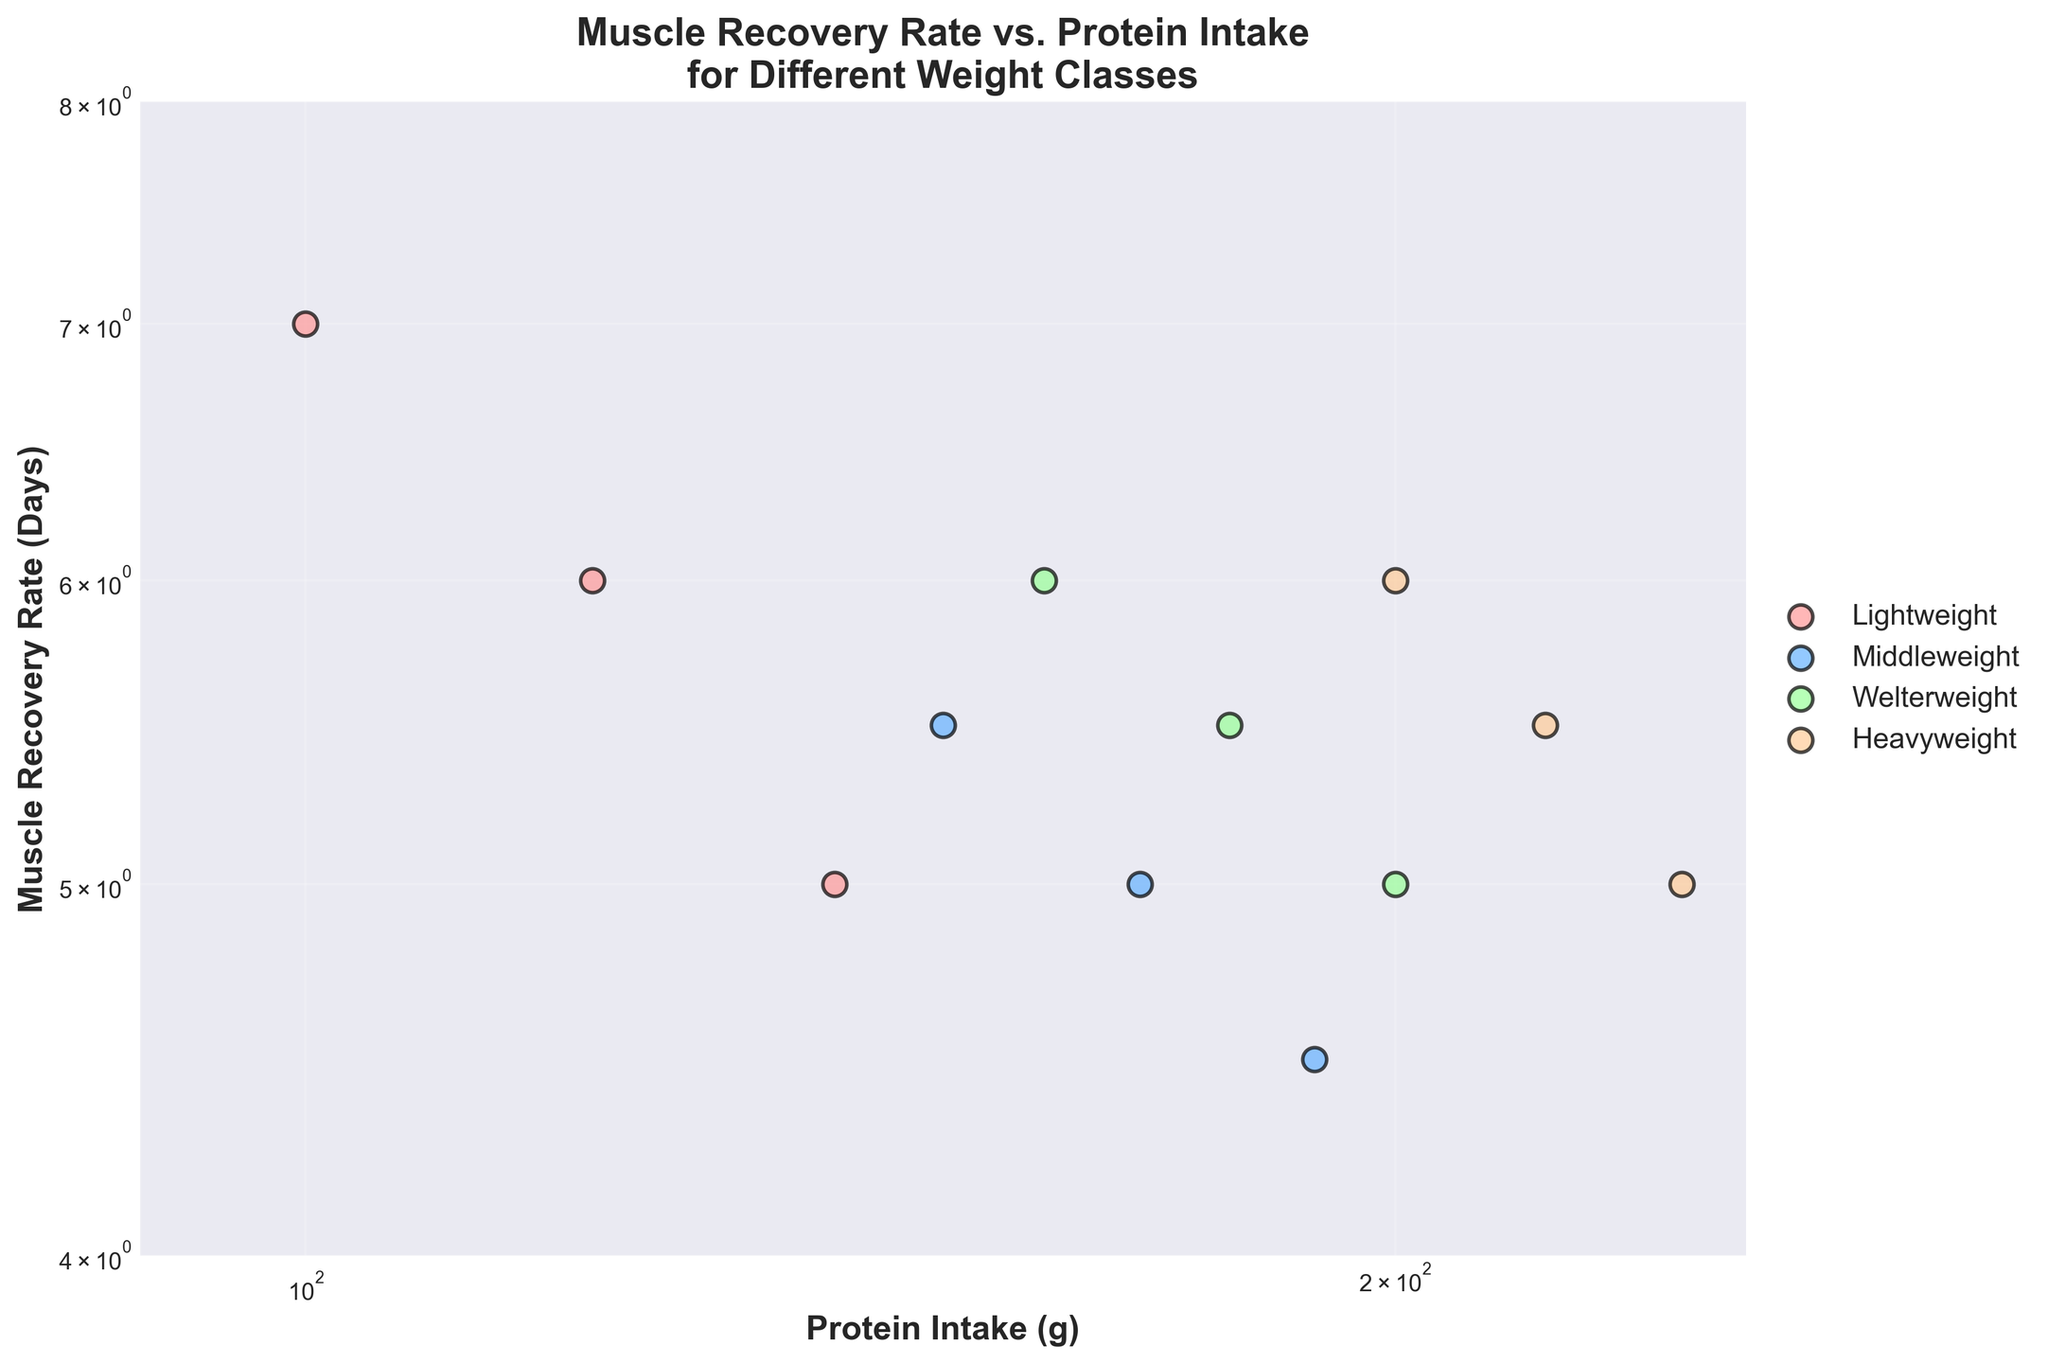What is the title of the plot? The title of the plot is written at the top and it reads: "Muscle Recovery Rate vs. Protein Intake for Different Weight Classes".
Answer: Muscle Recovery Rate vs. Protein Intake for Different Weight Classes What is the range of the x-axis? The range of the x-axis can be found at the bottom of the plot, from the lowest to the highest labeled value. It spans from 90 to 250 grams of protein intake.
Answer: 90 to 250 What is the range of the y-axis? The range of the y-axis can be found on the left side of the plot, from the lowest to the highest labeled value. It spans from 4 to 8 days of muscle recovery rate.
Answer: 4 to 8 How many different weight classes are represented in the plot? The number of different weight classes is indicated by the legend on the side of the plot. Each class has its unique label and color. There are four weight classes: Lightweight, Middleweight, Welterweight, and Heavyweight.
Answer: 4 Which weight class has the highest amount of protein intake shown? To determine the weight class with the highest protein intake, look at the rightmost data point in the plot. The highest value of protein intake is 240 grams, belonging to the Heavyweight class.
Answer: Heavyweight What is the protein intake for the data point with a muscle recovery rate of 5 Days in the Welterweight class? To find this, locate the data point along the y-axis at 5 Days recovery rate and identify the protein intake value on the x-axis within the Welterweight category. The protein intake is 200 grams.
Answer: 200 grams Between Middleweight and Welterweight, which class shows a better muscle recovery rate at a protein intake of approximately 170 grams? To compare, find the data points for both classes near 170 grams protein intake and compare their recovery rates. Middleweight at 170 grams shows a recovery rate of 5 days, while Welterweight at 180 grams (closest to 170) shows a recovery rate of 5.5 days. Thus, Middleweight has a better recovery rate.
Answer: Middleweight Do any data points for the Heavyweight class exhibit a muscle recovery rate of less than 5 days? Find all data points for the Heavyweight class and check their position on the y-axis to see if any fall below 5 days. None of the data points for the Heavyweight class have a muscle recovery rate of less than 5 days.
Answer: No What's the difference in muscle recovery rates between the data points with the highest and lowest protein intakes in the Lightweight class? Identify the highest and lowest protein intakes for Lightweight (100g and 140g, respectively) and note their corresponding recovery rates (7 days and 5 days). The difference is 7 - 5 = 2 days.
Answer: 2 days 